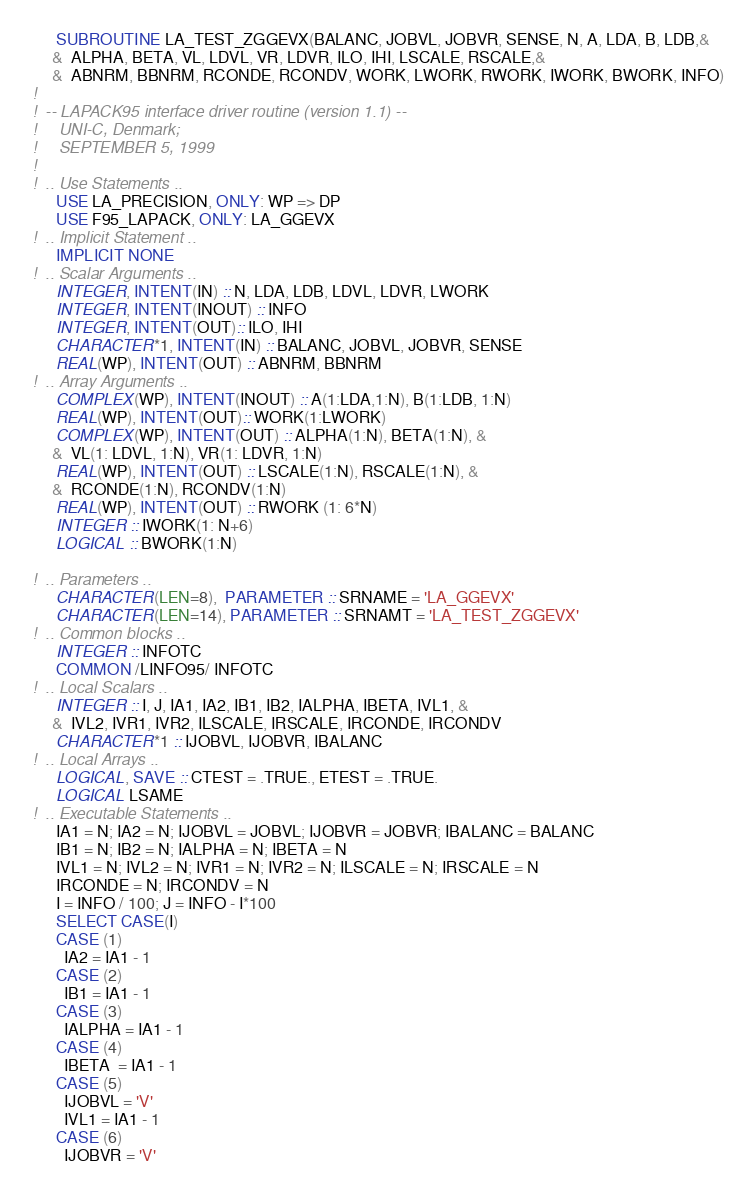<code> <loc_0><loc_0><loc_500><loc_500><_FORTRAN_>      SUBROUTINE LA_TEST_ZGGEVX(BALANC, JOBVL, JOBVR, SENSE, N, A, LDA, B, LDB,&
     &  ALPHA, BETA, VL, LDVL, VR, LDVR, ILO, IHI, LSCALE, RSCALE,&
     &  ABNRM, BBNRM, RCONDE, RCONDV, WORK, LWORK, RWORK, IWORK, BWORK, INFO)
!
!  -- LAPACK95 interface driver routine (version 1.1) --
!     UNI-C, Denmark;
!     SEPTEMBER 5, 1999
!
!  .. Use Statements ..
      USE LA_PRECISION, ONLY: WP => DP
      USE F95_LAPACK, ONLY: LA_GGEVX
!  .. Implicit Statement ..
      IMPLICIT NONE
!  .. Scalar Arguments ..
      INTEGER, INTENT(IN) :: N, LDA, LDB, LDVL, LDVR, LWORK
      INTEGER, INTENT(INOUT) :: INFO
      INTEGER, INTENT(OUT):: ILO, IHI
      CHARACTER*1, INTENT(IN) :: BALANC, JOBVL, JOBVR, SENSE
      REAL(WP), INTENT(OUT) :: ABNRM, BBNRM
!  .. Array Arguments ..
      COMPLEX(WP), INTENT(INOUT) :: A(1:LDA,1:N), B(1:LDB, 1:N)
      REAL(WP), INTENT(OUT):: WORK(1:LWORK)
      COMPLEX(WP), INTENT(OUT) :: ALPHA(1:N), BETA(1:N), &
     &  VL(1: LDVL, 1:N), VR(1: LDVR, 1:N)
      REAL(WP), INTENT(OUT) :: LSCALE(1:N), RSCALE(1:N), &
     &  RCONDE(1:N), RCONDV(1:N)
      REAL(WP), INTENT(OUT) :: RWORK (1: 6*N)
      INTEGER :: IWORK(1: N+6)
      LOGICAL :: BWORK(1:N)
      
!  .. Parameters ..
      CHARACTER(LEN=8),  PARAMETER :: SRNAME = 'LA_GGEVX'
      CHARACTER(LEN=14), PARAMETER :: SRNAMT = 'LA_TEST_ZGGEVX'
!  .. Common blocks ..
      INTEGER :: INFOTC
      COMMON /LINFO95/ INFOTC
!  .. Local Scalars ..
      INTEGER :: I, J, IA1, IA2, IB1, IB2, IALPHA, IBETA, IVL1, &
     &  IVL2, IVR1, IVR2, ILSCALE, IRSCALE, IRCONDE, IRCONDV
      CHARACTER*1 :: IJOBVL, IJOBVR, IBALANC
!  .. Local Arrays ..
      LOGICAL, SAVE :: CTEST = .TRUE., ETEST = .TRUE.
      LOGICAL LSAME
!  .. Executable Statements ..
      IA1 = N; IA2 = N; IJOBVL = JOBVL; IJOBVR = JOBVR; IBALANC = BALANC
      IB1 = N; IB2 = N; IALPHA = N; IBETA = N
      IVL1 = N; IVL2 = N; IVR1 = N; IVR2 = N; ILSCALE = N; IRSCALE = N
      IRCONDE = N; IRCONDV = N
      I = INFO / 100; J = INFO - I*100
      SELECT CASE(I)
      CASE (1)
        IA2 = IA1 - 1
      CASE (2)
        IB1 = IA1 - 1
      CASE (3)
        IALPHA = IA1 - 1
      CASE (4)
        IBETA  = IA1 - 1
      CASE (5)
        IJOBVL = 'V'
        IVL1 = IA1 - 1
      CASE (6)
        IJOBVR = 'V'</code> 